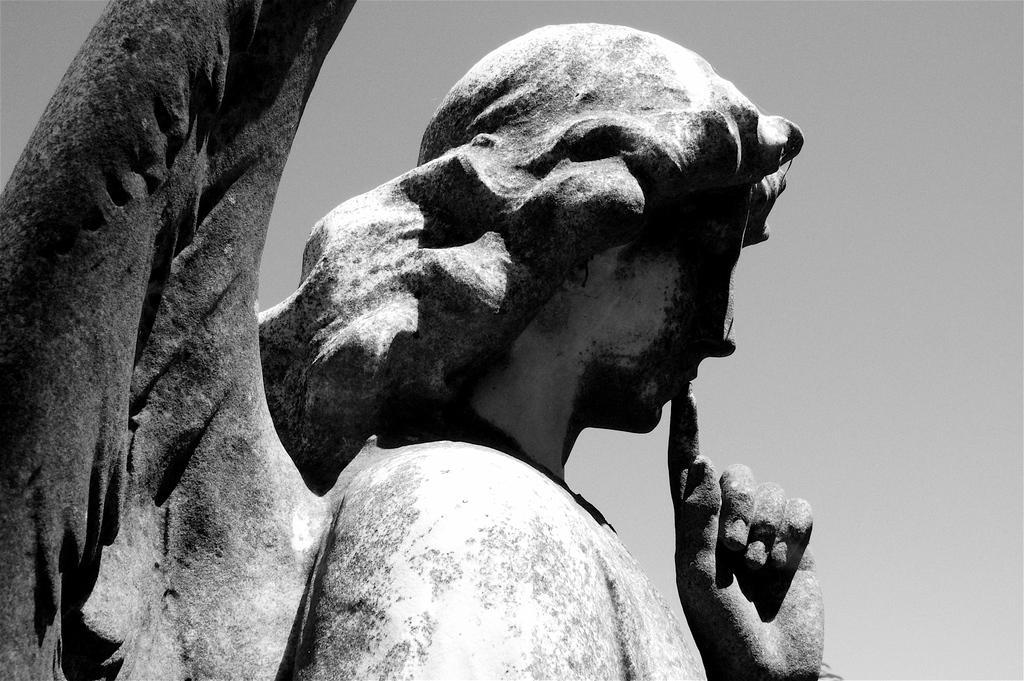Can you describe this image briefly? This image consists of a sculpture made up of rock. In the background, there is sky. 